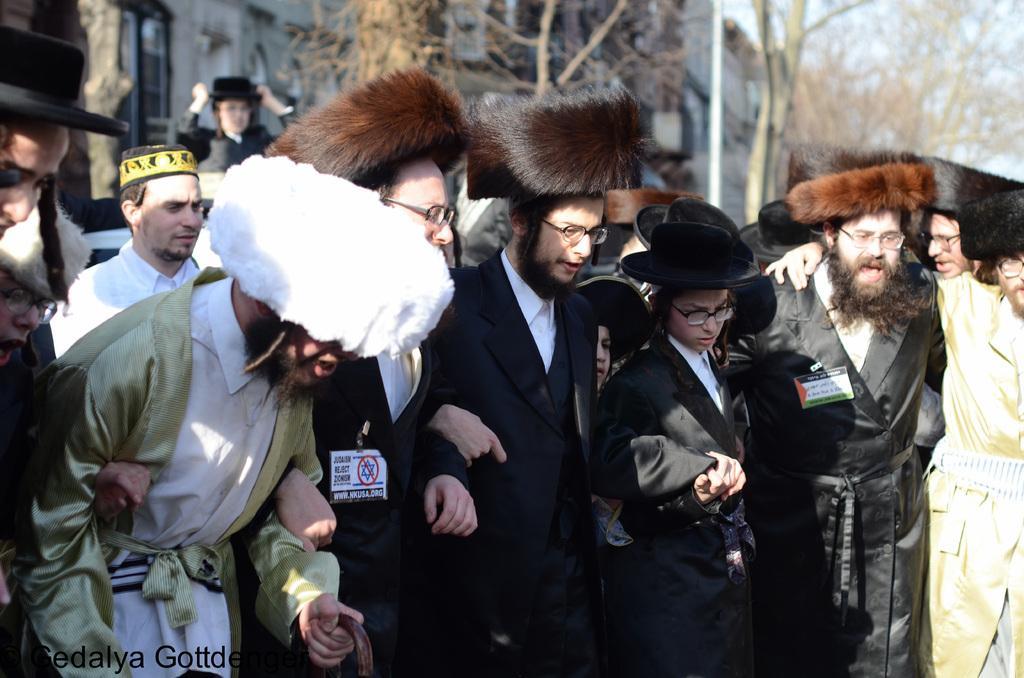How would you summarize this image in a sentence or two? In this picture I can see a building and few trees and few people standing and holding their hands and all of them wore caps on their heads and spectacles and I can see text on the bottom left corner of the picture. 